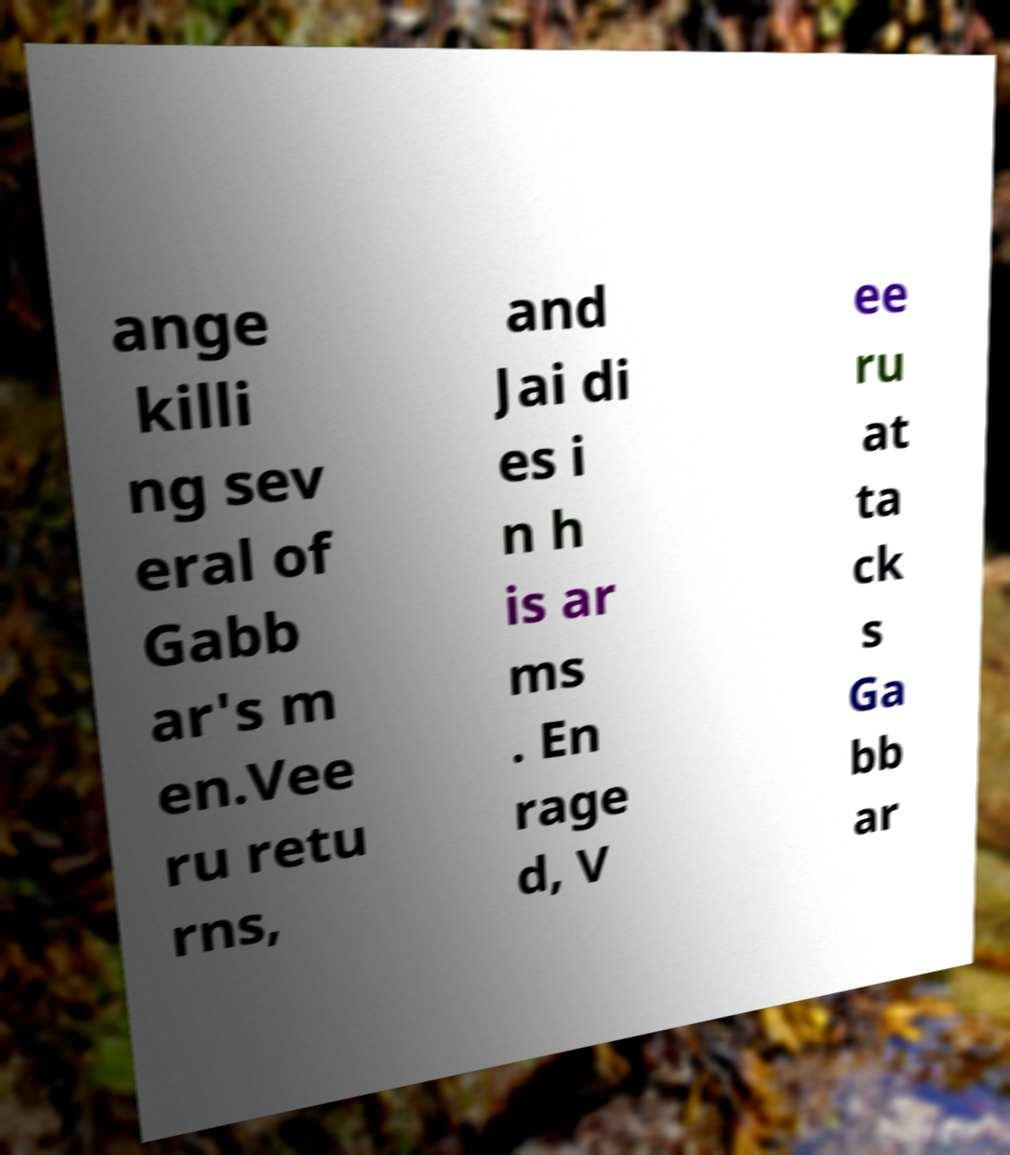I need the written content from this picture converted into text. Can you do that? ange killi ng sev eral of Gabb ar's m en.Vee ru retu rns, and Jai di es i n h is ar ms . En rage d, V ee ru at ta ck s Ga bb ar 